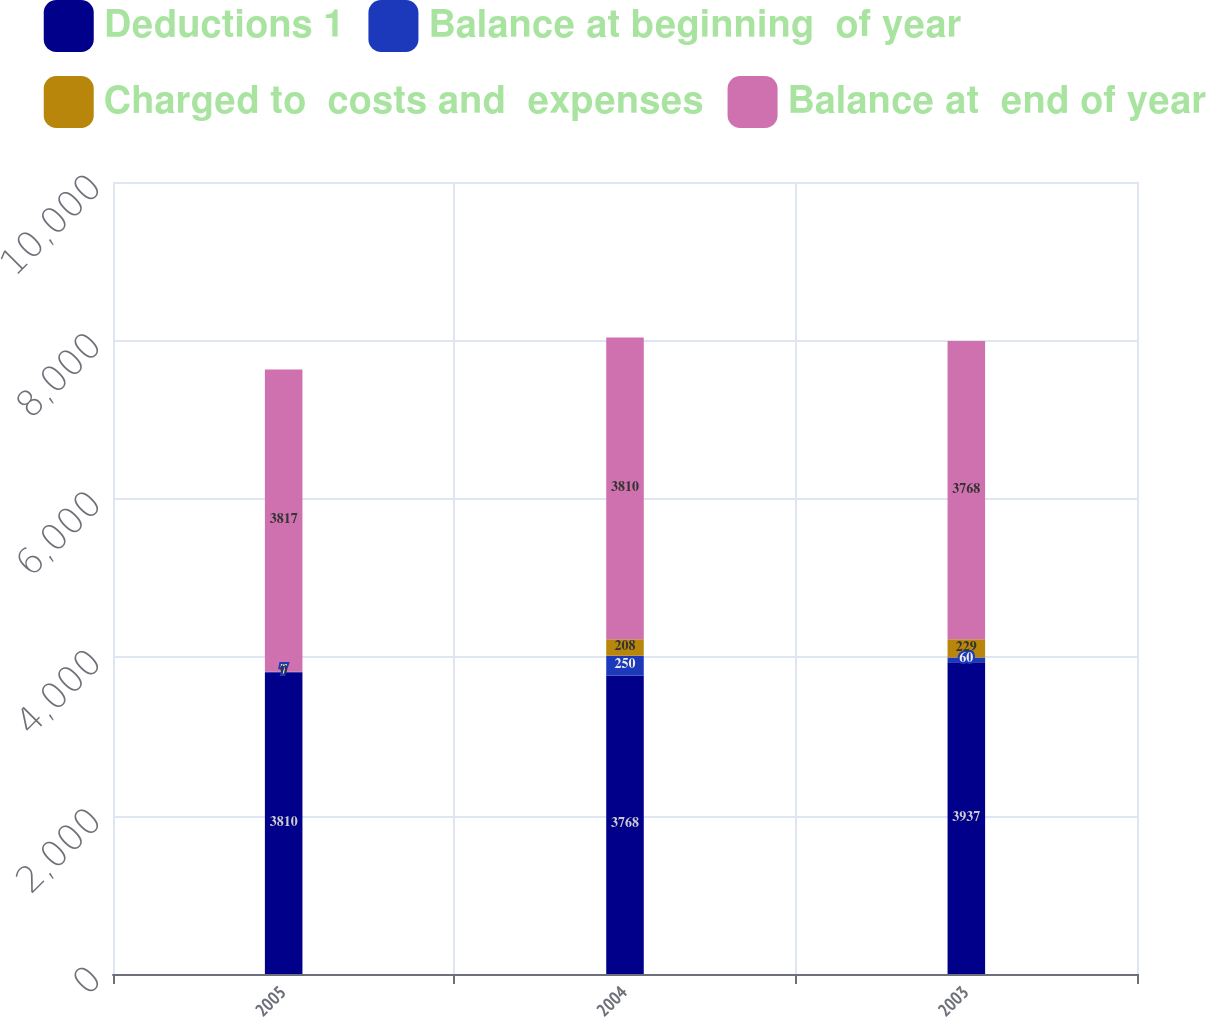Convert chart. <chart><loc_0><loc_0><loc_500><loc_500><stacked_bar_chart><ecel><fcel>2005<fcel>2004<fcel>2003<nl><fcel>Deductions 1<fcel>3810<fcel>3768<fcel>3937<nl><fcel>Balance at beginning  of year<fcel>7<fcel>250<fcel>60<nl><fcel>Charged to  costs and  expenses<fcel>0<fcel>208<fcel>229<nl><fcel>Balance at  end of year<fcel>3817<fcel>3810<fcel>3768<nl></chart> 